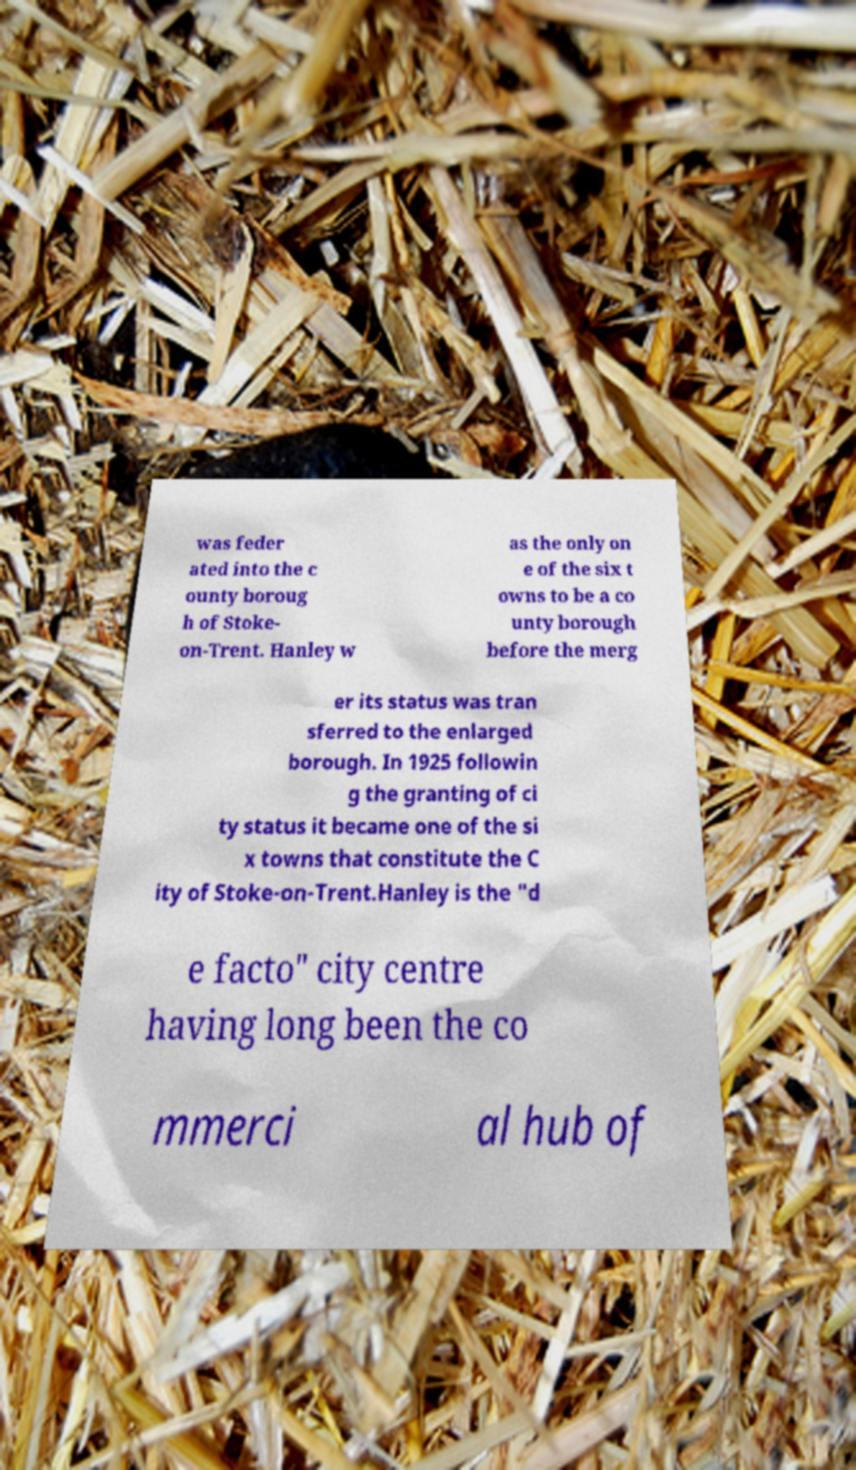Can you read and provide the text displayed in the image?This photo seems to have some interesting text. Can you extract and type it out for me? was feder ated into the c ounty boroug h of Stoke- on-Trent. Hanley w as the only on e of the six t owns to be a co unty borough before the merg er its status was tran sferred to the enlarged borough. In 1925 followin g the granting of ci ty status it became one of the si x towns that constitute the C ity of Stoke-on-Trent.Hanley is the "d e facto" city centre having long been the co mmerci al hub of 